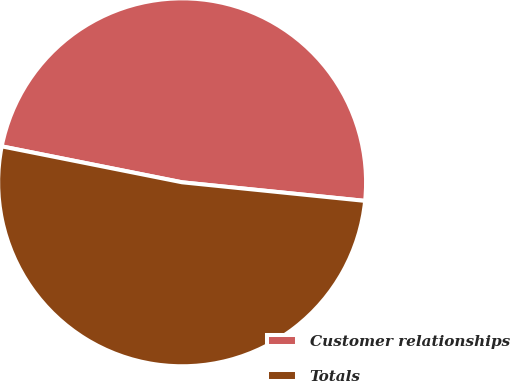Convert chart. <chart><loc_0><loc_0><loc_500><loc_500><pie_chart><fcel>Customer relationships<fcel>Totals<nl><fcel>48.48%<fcel>51.52%<nl></chart> 